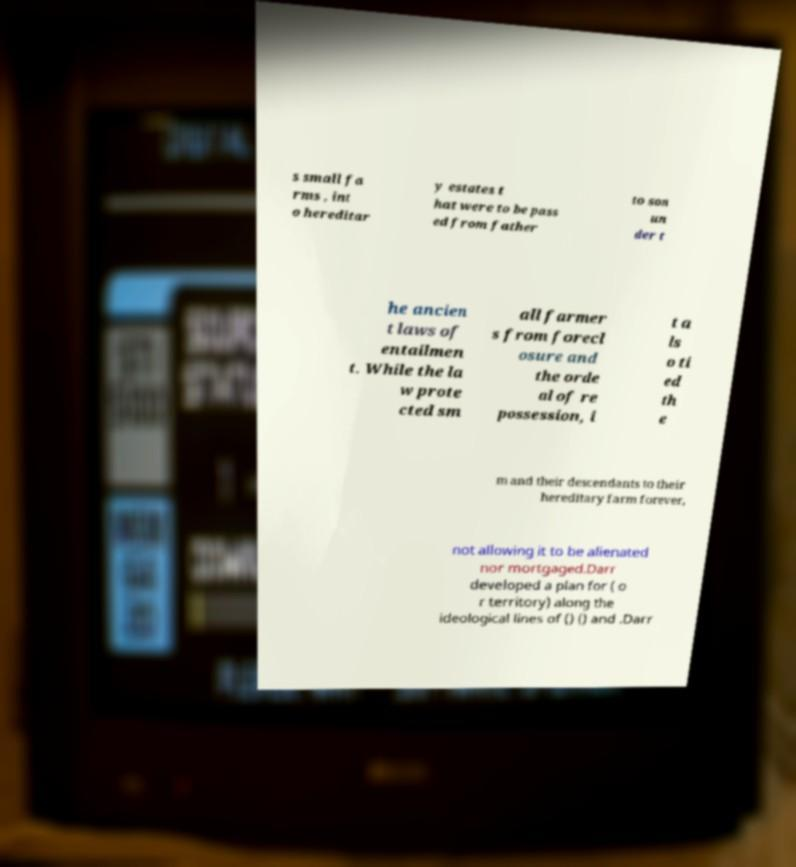Could you extract and type out the text from this image? s small fa rms , int o hereditar y estates t hat were to be pass ed from father to son un der t he ancien t laws of entailmen t. While the la w prote cted sm all farmer s from forecl osure and the orde al of re possession, i t a ls o ti ed th e m and their descendants to their hereditary farm forever, not allowing it to be alienated nor mortgaged.Darr developed a plan for ( o r territory) along the ideological lines of () () and .Darr 